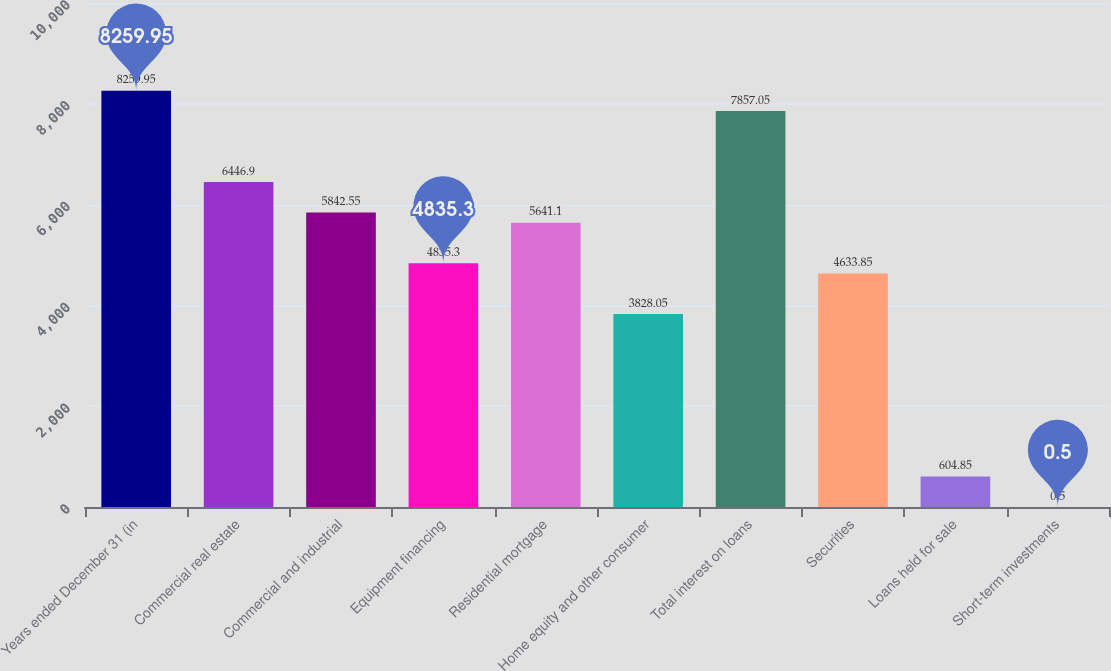Convert chart to OTSL. <chart><loc_0><loc_0><loc_500><loc_500><bar_chart><fcel>Years ended December 31 (in<fcel>Commercial real estate<fcel>Commercial and industrial<fcel>Equipment financing<fcel>Residential mortgage<fcel>Home equity and other consumer<fcel>Total interest on loans<fcel>Securities<fcel>Loans held for sale<fcel>Short-term investments<nl><fcel>8259.95<fcel>6446.9<fcel>5842.55<fcel>4835.3<fcel>5641.1<fcel>3828.05<fcel>7857.05<fcel>4633.85<fcel>604.85<fcel>0.5<nl></chart> 